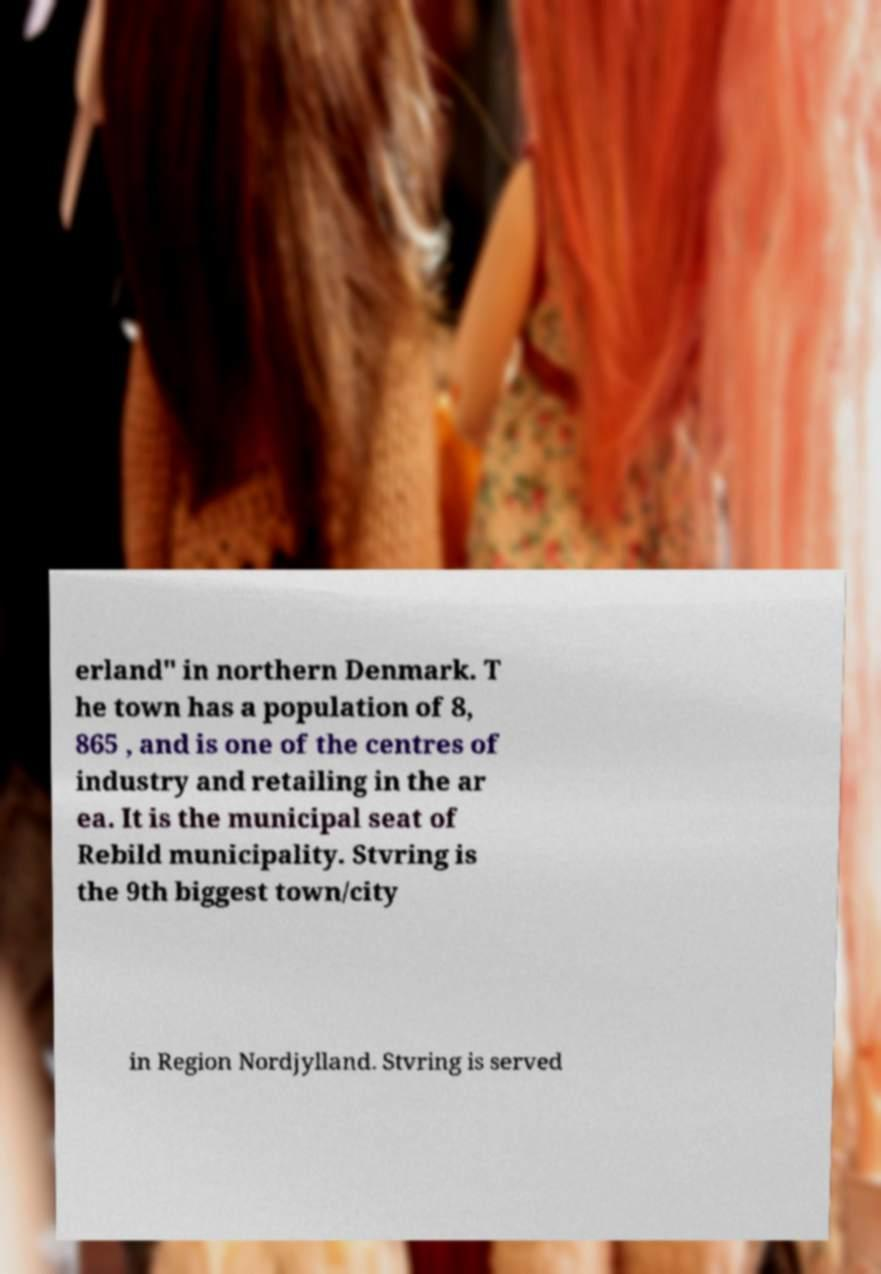Could you extract and type out the text from this image? erland" in northern Denmark. T he town has a population of 8, 865 , and is one of the centres of industry and retailing in the ar ea. It is the municipal seat of Rebild municipality. Stvring is the 9th biggest town/city in Region Nordjylland. Stvring is served 